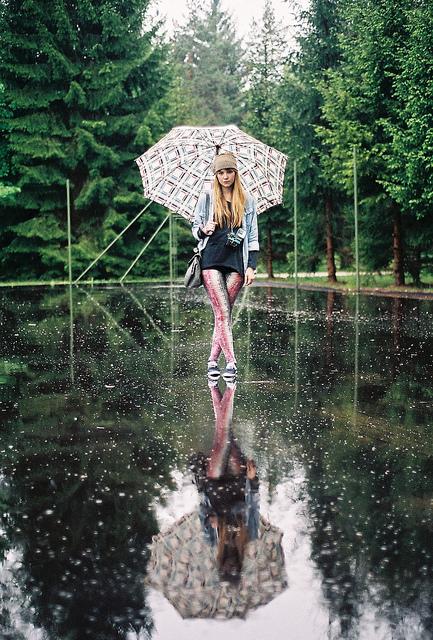Is it raining in this picture?
Short answer required. Yes. Is the surface wet?
Be succinct. Yes. Is the water calm?
Write a very short answer. Yes. 